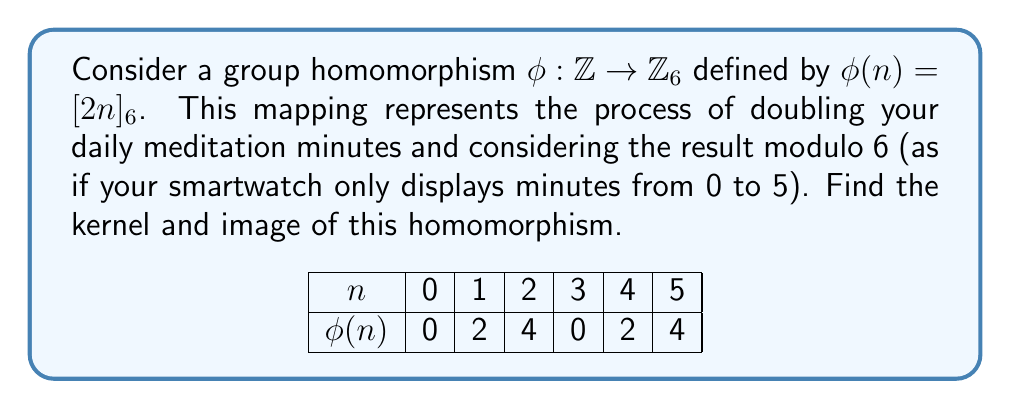Give your solution to this math problem. Let's approach this step-by-step:

1) First, let's recall the definitions:
   - The kernel of a homomorphism $\phi$ is the set of all elements in the domain that map to the identity element in the codomain.
   - The image of a homomorphism $\phi$ is the set of all elements in the codomain that are mapped to by at least one element in the domain.

2) For $\mathbb{Z}_6$, the identity element is $[0]_6$.

3) To find the kernel, we need to solve the equation:
   $\phi(n) = [2n]_6 = [0]_6$
   This is equivalent to solving:
   $2n \equiv 0 \pmod{6}$
   $n \equiv 0 \pmod{3}$

4) Therefore, the kernel consists of all multiples of 3 in $\mathbb{Z}$:
   $\ker(\phi) = \{..., -6, -3, 0, 3, 6, ...\} = 3\mathbb{Z}$

5) To find the image, let's consider what elements we can get in $\mathbb{Z}_6$:
   $\phi(0) = [0]_6$
   $\phi(1) = [2]_6$
   $\phi(2) = [4]_6$
   $\phi(3) = [0]_6$
   $\phi(4) = [2]_6$
   $\phi(5) = [4]_6$

6) We see that the image consists of $[0]_6, [2]_6,$ and $[4]_6$.

Therefore, $\text{Im}(\phi) = \{[0]_6, [2]_6, [4]_6\}$.
Answer: $\ker(\phi) = 3\mathbb{Z}$, $\text{Im}(\phi) = \{[0]_6, [2]_6, [4]_6\}$ 